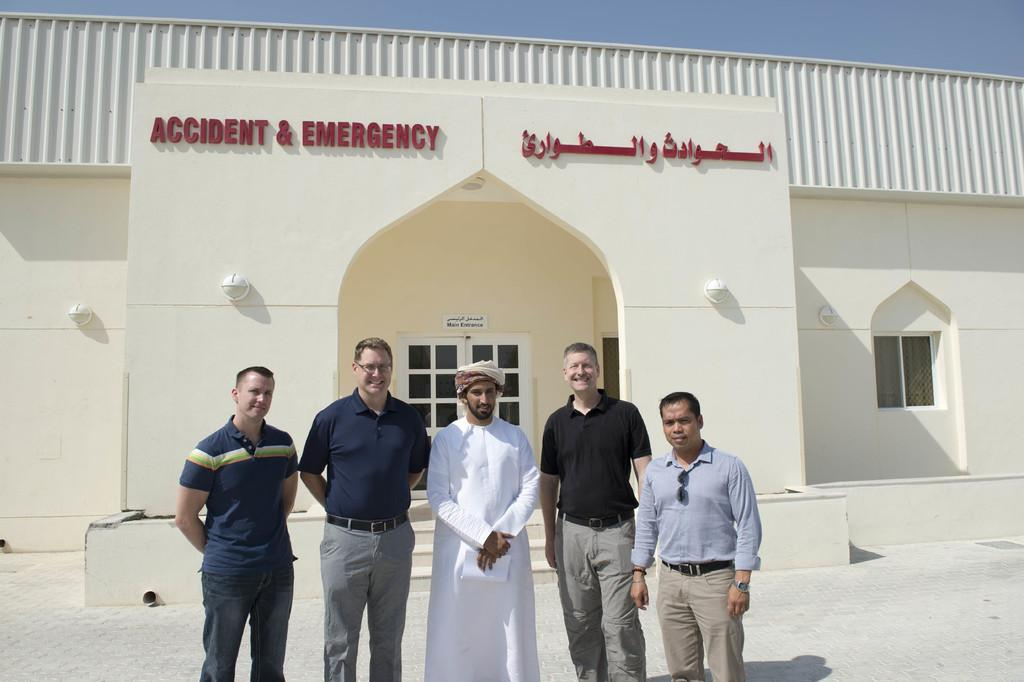What are the people in the image doing? The people in the image are standing on the ground. What structure can be seen in the image? There is a building visible in the image. What can be seen in the background of the image? The sky is visible in the background of the image. What type of brain is visible in the image? There is no brain visible in the image; it features people standing on the ground and a building. How many houses are present in the image? There is no house present in the image; it features a building, but not a house specifically. 